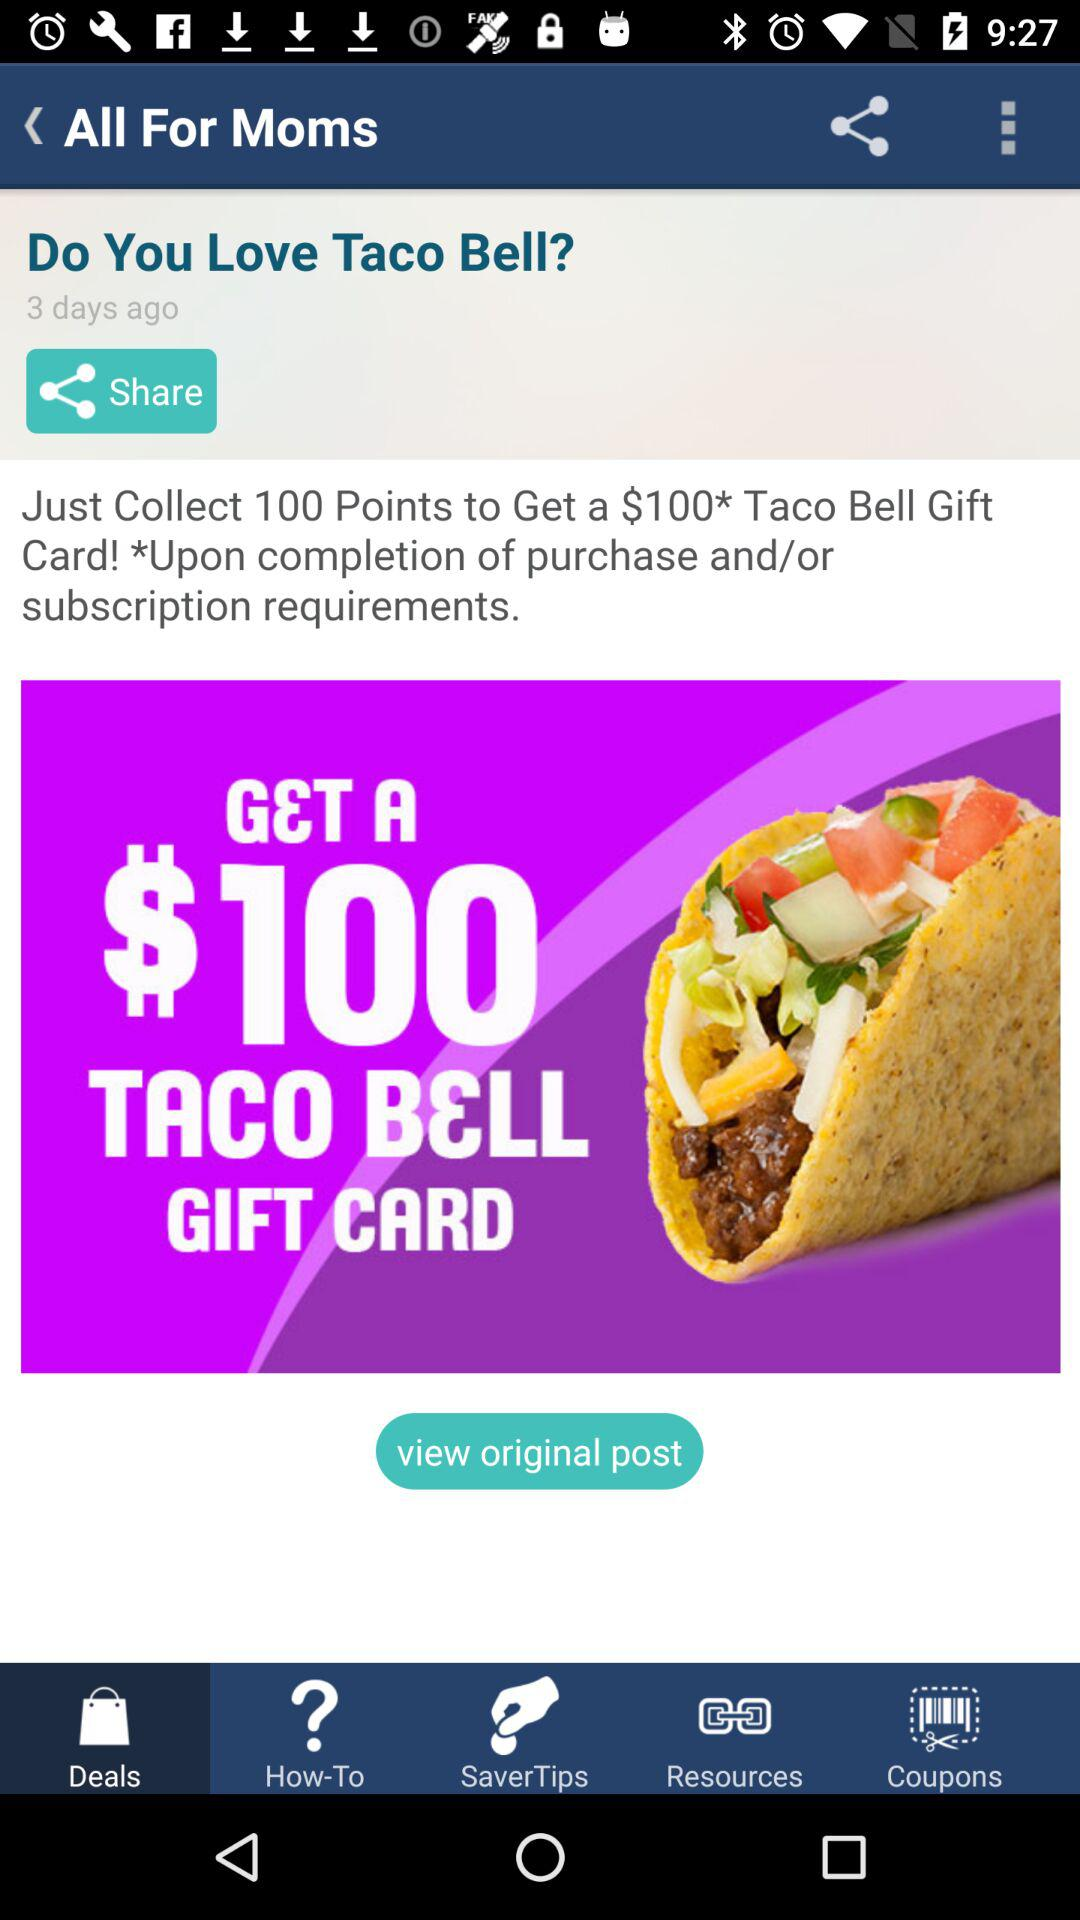What is the name of the card? The name of the card is Taco Bell Gift Card. 